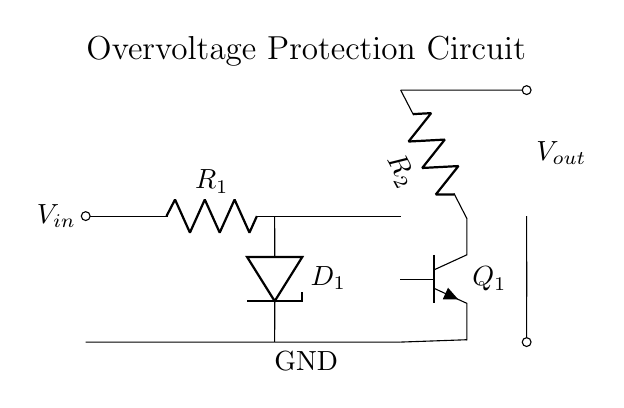What type of diode is used in this circuit? The circuit includes a Zener diode, identified by the label D1, which is placed in reverse bias to regulate voltage when the input exceeds a certain level.
Answer: Zener diode What is the function of resistor R1? Resistor R1 serves to limit the input current flowing into the Zener diode, protecting it from excessive current that could damage it or create thermal issues.
Answer: Current limiting How many transistors are present in this circuit? The circuit contains one transistor, identified as Q1, which is responsible for switching and controlling the output based on the input voltage conditions.
Answer: One What is the main purpose of this circuit? The primary function of the circuit is to provide overvoltage protection, which prevents excess voltage from reaching connected high-end consumer electronics, thereby ensuring safety and reliability.
Answer: Overvoltage protection What occurs when the input voltage exceeds a specified threshold? When the input voltage exceeds this threshold, the Zener diode conducts, allowing it to shunt excess voltage away from the output, and simultaneously turning on the transistor Q1 to further regulate the circuit.
Answer: Voltage shunting Where do you find the ground reference in this circuit? The ground reference is indicated at the point labeled GND, which is connected to the lower terminal of the Zener diode and serves as the common return path for the circuit.
Answer: Ground reference 